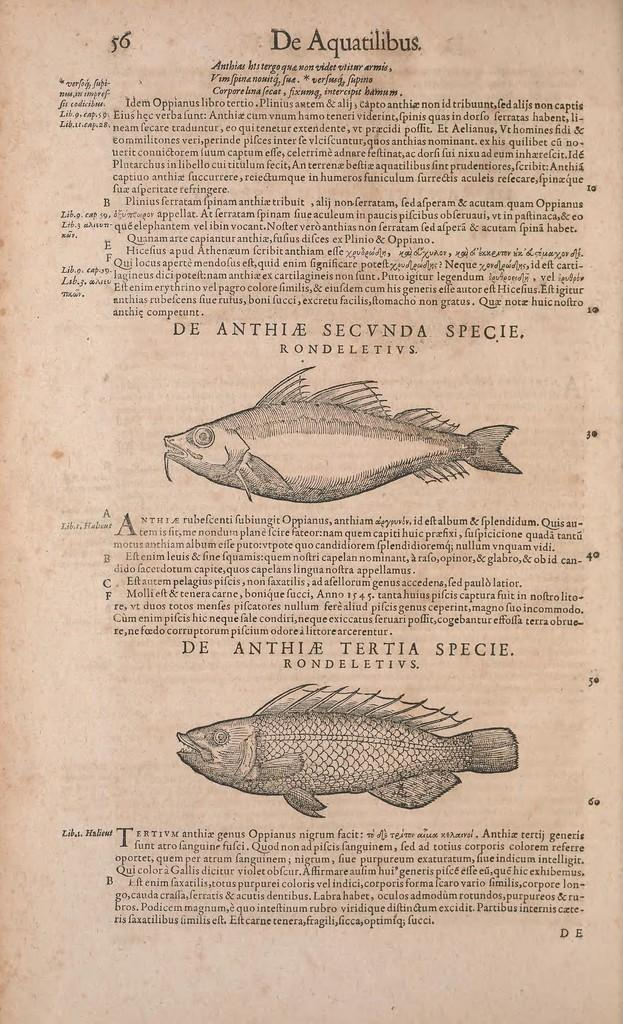What is the main subject of the paper in the image? The paper contains images of fishes. What else can be found on the paper besides the images of fishes? There is written matter on the paper. What type of garden is depicted in the image? There is no garden present in the image; it features a paper with images of fishes and written matter. 